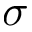Convert formula to latex. <formula><loc_0><loc_0><loc_500><loc_500>\sigma</formula> 